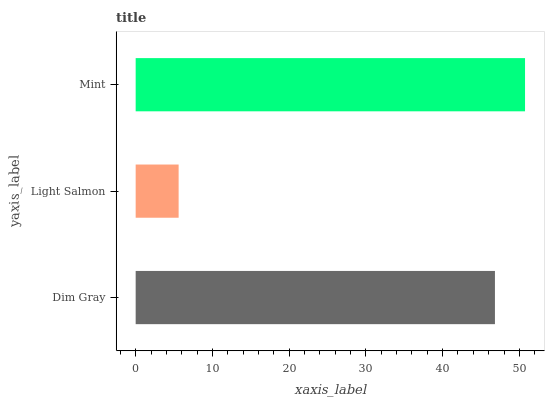Is Light Salmon the minimum?
Answer yes or no. Yes. Is Mint the maximum?
Answer yes or no. Yes. Is Mint the minimum?
Answer yes or no. No. Is Light Salmon the maximum?
Answer yes or no. No. Is Mint greater than Light Salmon?
Answer yes or no. Yes. Is Light Salmon less than Mint?
Answer yes or no. Yes. Is Light Salmon greater than Mint?
Answer yes or no. No. Is Mint less than Light Salmon?
Answer yes or no. No. Is Dim Gray the high median?
Answer yes or no. Yes. Is Dim Gray the low median?
Answer yes or no. Yes. Is Mint the high median?
Answer yes or no. No. Is Mint the low median?
Answer yes or no. No. 